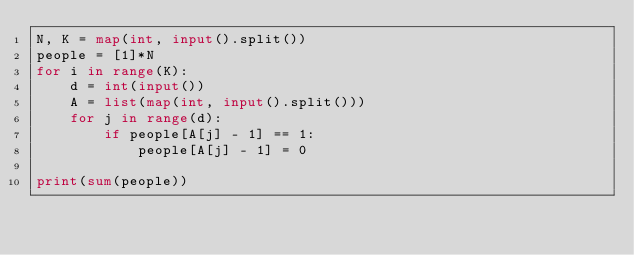Convert code to text. <code><loc_0><loc_0><loc_500><loc_500><_Python_>N, K = map(int, input().split())
people = [1]*N
for i in range(K):
    d = int(input())
    A = list(map(int, input().split()))
    for j in range(d):
        if people[A[j] - 1] == 1:
            people[A[j] - 1] = 0

print(sum(people))</code> 